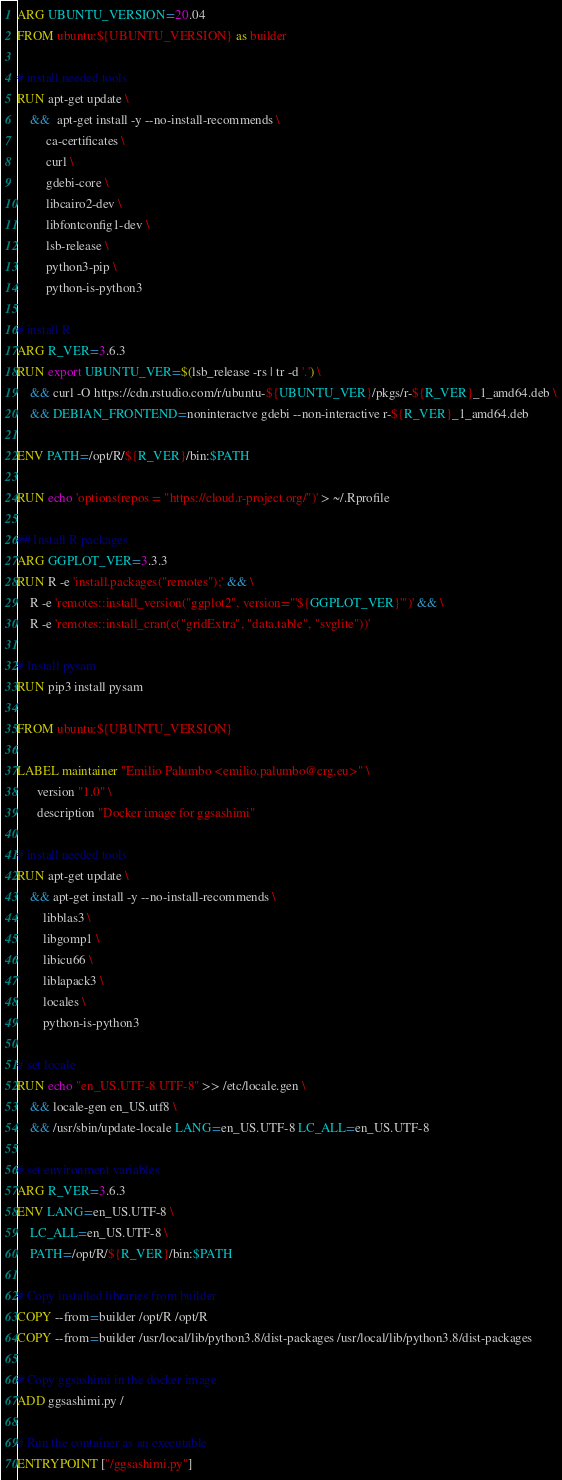Convert code to text. <code><loc_0><loc_0><loc_500><loc_500><_Dockerfile_>ARG UBUNTU_VERSION=20.04
FROM ubuntu:${UBUNTU_VERSION} as builder

# install needed tools
RUN apt-get update \
    &&  apt-get install -y --no-install-recommends \
         ca-certificates \
         curl \
         gdebi-core \
         libcairo2-dev \
         libfontconfig1-dev \
         lsb-release \
         python3-pip \
         python-is-python3

# install R
ARG R_VER=3.6.3
RUN export UBUNTU_VER=$(lsb_release -rs | tr -d '.') \
    && curl -O https://cdn.rstudio.com/r/ubuntu-${UBUNTU_VER}/pkgs/r-${R_VER}_1_amd64.deb \
    && DEBIAN_FRONTEND=noninteractve gdebi --non-interactive r-${R_VER}_1_amd64.deb

ENV PATH=/opt/R/${R_VER}/bin:$PATH

RUN echo 'options(repos = "https://cloud.r-project.org/")' > ~/.Rprofile

## Install R packages
ARG GGPLOT_VER=3.3.3
RUN R -e 'install.packages("remotes");' && \
    R -e 'remotes::install_version("ggplot2", version="'${GGPLOT_VER}'")' && \
    R -e 'remotes::install_cran(c("gridExtra", "data.table", "svglite"))'

# Install pysam
RUN pip3 install pysam

FROM ubuntu:${UBUNTU_VERSION}

LABEL maintainer "Emilio Palumbo <emilio.palumbo@crg.eu>" \
      version "1.0" \
      description "Docker image for ggsashimi"

# install needed tools
RUN apt-get update \
    && apt-get install -y --no-install-recommends \
        libblas3 \
        libgomp1 \
        libicu66 \
        liblapack3 \
        locales \
        python-is-python3

# set locale
RUN echo "en_US.UTF-8 UTF-8" >> /etc/locale.gen \
    && locale-gen en_US.utf8 \
    && /usr/sbin/update-locale LANG=en_US.UTF-8 LC_ALL=en_US.UTF-8

# set environment variables
ARG R_VER=3.6.3
ENV LANG=en_US.UTF-8 \
    LC_ALL=en_US.UTF-8 \
    PATH=/opt/R/${R_VER}/bin:$PATH

# Copy installed libraries from builder
COPY --from=builder /opt/R /opt/R
COPY --from=builder /usr/local/lib/python3.8/dist-packages /usr/local/lib/python3.8/dist-packages

# Copy ggsashimi in the docker image
ADD ggsashimi.py /

# Run the container as an executable
ENTRYPOINT ["/ggsashimi.py"]

</code> 